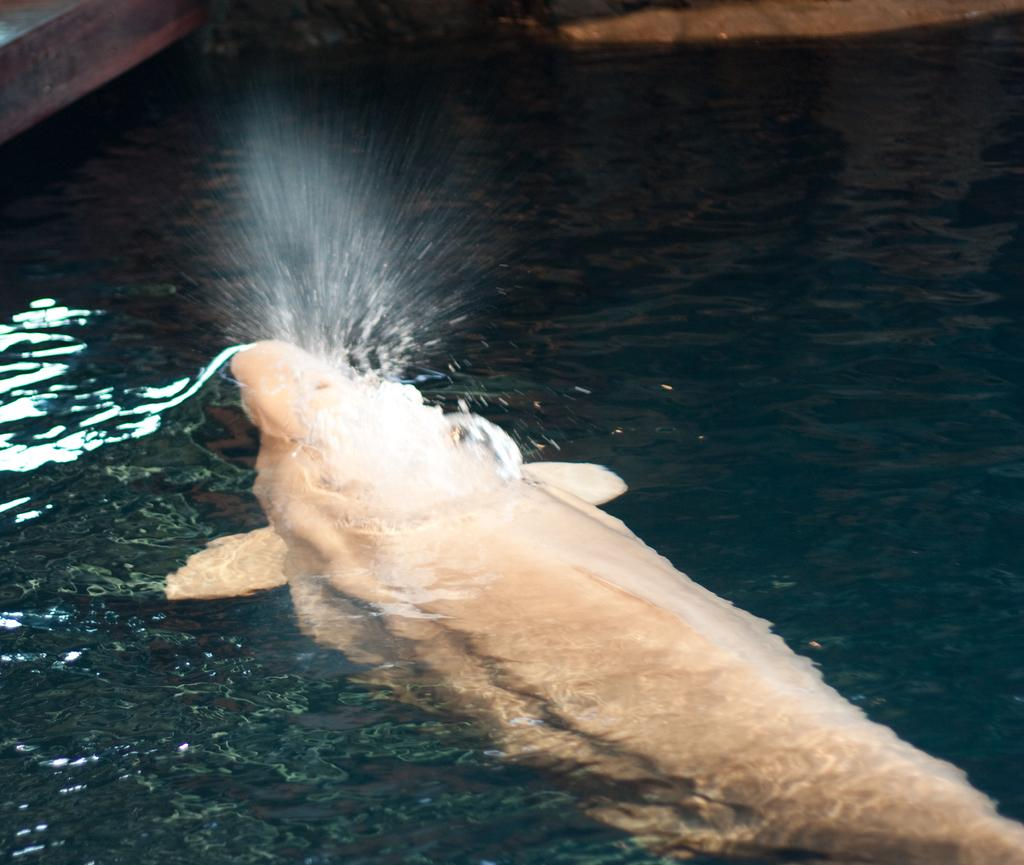What is the main subject of subject of the image? There is a fish in the image. Where is the fish located? The fish is in the water. What type of skirt is the fish wearing in the image? There is no skirt present in the image, as the subject is a fish in the water. 